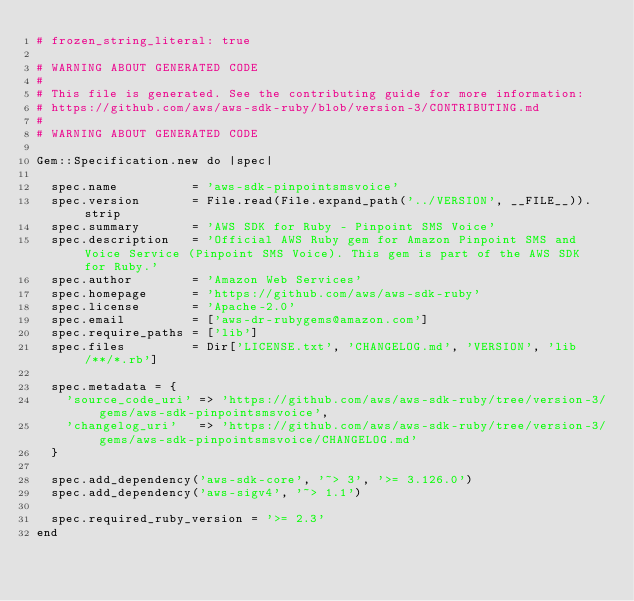Convert code to text. <code><loc_0><loc_0><loc_500><loc_500><_Ruby_># frozen_string_literal: true

# WARNING ABOUT GENERATED CODE
#
# This file is generated. See the contributing guide for more information:
# https://github.com/aws/aws-sdk-ruby/blob/version-3/CONTRIBUTING.md
#
# WARNING ABOUT GENERATED CODE

Gem::Specification.new do |spec|

  spec.name          = 'aws-sdk-pinpointsmsvoice'
  spec.version       = File.read(File.expand_path('../VERSION', __FILE__)).strip
  spec.summary       = 'AWS SDK for Ruby - Pinpoint SMS Voice'
  spec.description   = 'Official AWS Ruby gem for Amazon Pinpoint SMS and Voice Service (Pinpoint SMS Voice). This gem is part of the AWS SDK for Ruby.'
  spec.author        = 'Amazon Web Services'
  spec.homepage      = 'https://github.com/aws/aws-sdk-ruby'
  spec.license       = 'Apache-2.0'
  spec.email         = ['aws-dr-rubygems@amazon.com']
  spec.require_paths = ['lib']
  spec.files         = Dir['LICENSE.txt', 'CHANGELOG.md', 'VERSION', 'lib/**/*.rb']

  spec.metadata = {
    'source_code_uri' => 'https://github.com/aws/aws-sdk-ruby/tree/version-3/gems/aws-sdk-pinpointsmsvoice',
    'changelog_uri'   => 'https://github.com/aws/aws-sdk-ruby/tree/version-3/gems/aws-sdk-pinpointsmsvoice/CHANGELOG.md'
  }

  spec.add_dependency('aws-sdk-core', '~> 3', '>= 3.126.0')
  spec.add_dependency('aws-sigv4', '~> 1.1')

  spec.required_ruby_version = '>= 2.3'
end
</code> 